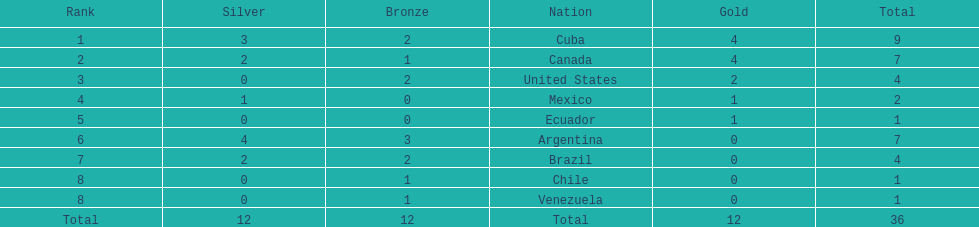What were all of the nations involved in the canoeing at the 2011 pan american games? Cuba, Canada, United States, Mexico, Ecuador, Argentina, Brazil, Chile, Venezuela, Total. Of these, which had a numbered rank? Cuba, Canada, United States, Mexico, Ecuador, Argentina, Brazil, Chile, Venezuela. From these, which had the highest number of bronze? Argentina. 